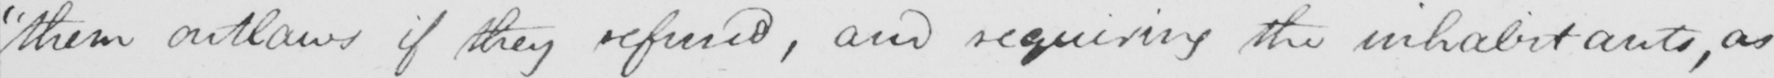Can you read and transcribe this handwriting? "them outlaws if they refused, and requiring the inhabitants, as 